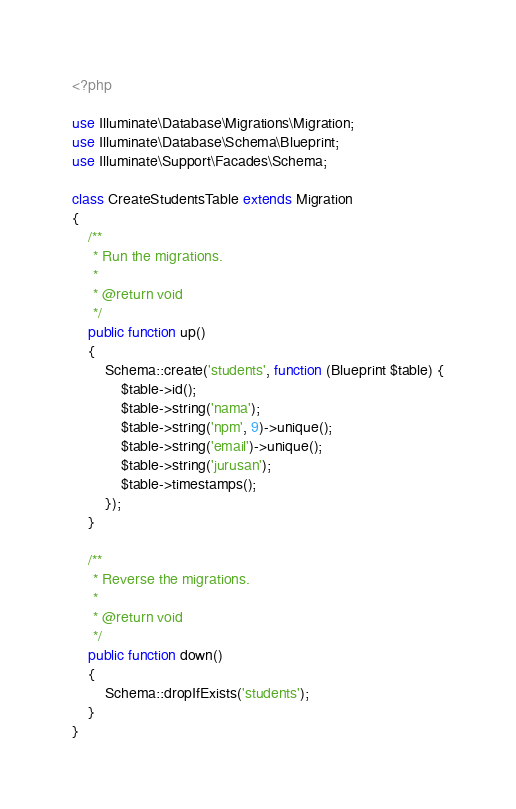Convert code to text. <code><loc_0><loc_0><loc_500><loc_500><_PHP_><?php

use Illuminate\Database\Migrations\Migration;
use Illuminate\Database\Schema\Blueprint;
use Illuminate\Support\Facades\Schema;

class CreateStudentsTable extends Migration
{
    /**
     * Run the migrations.
     *
     * @return void
     */
    public function up()
    {
        Schema::create('students', function (Blueprint $table) {
            $table->id();
            $table->string('nama');
            $table->string('npm', 9)->unique();
            $table->string('email')->unique();
            $table->string('jurusan');
            $table->timestamps();
        });
    }

    /**
     * Reverse the migrations.
     *
     * @return void
     */
    public function down()
    {
        Schema::dropIfExists('students');
    }
}
</code> 